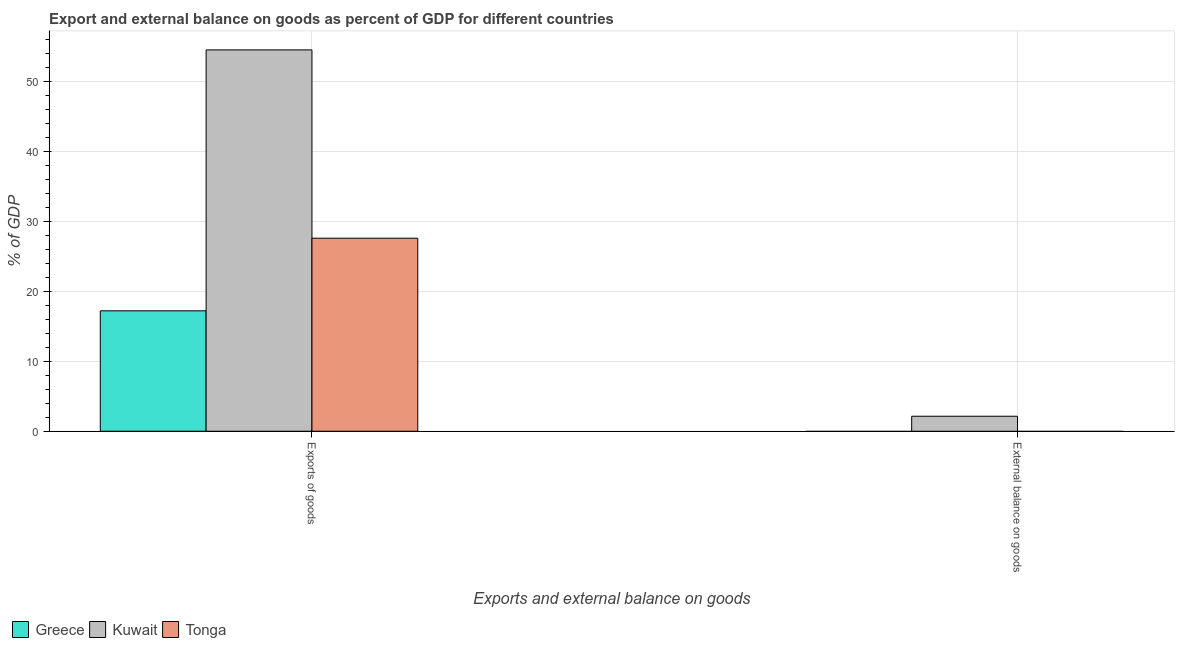Are the number of bars per tick equal to the number of legend labels?
Offer a very short reply. No. What is the label of the 2nd group of bars from the left?
Your response must be concise. External balance on goods. What is the export of goods as percentage of gdp in Tonga?
Ensure brevity in your answer.  27.59. Across all countries, what is the maximum export of goods as percentage of gdp?
Offer a very short reply. 54.5. Across all countries, what is the minimum external balance on goods as percentage of gdp?
Your answer should be compact. 0. In which country was the external balance on goods as percentage of gdp maximum?
Provide a succinct answer. Kuwait. What is the total external balance on goods as percentage of gdp in the graph?
Give a very brief answer. 2.14. What is the difference between the export of goods as percentage of gdp in Tonga and that in Kuwait?
Give a very brief answer. -26.92. What is the difference between the export of goods as percentage of gdp in Kuwait and the external balance on goods as percentage of gdp in Tonga?
Give a very brief answer. 54.5. What is the average external balance on goods as percentage of gdp per country?
Your response must be concise. 0.71. What is the difference between the export of goods as percentage of gdp and external balance on goods as percentage of gdp in Kuwait?
Provide a succinct answer. 52.36. In how many countries, is the external balance on goods as percentage of gdp greater than 6 %?
Provide a succinct answer. 0. What is the ratio of the export of goods as percentage of gdp in Tonga to that in Greece?
Provide a short and direct response. 1.6. In how many countries, is the export of goods as percentage of gdp greater than the average export of goods as percentage of gdp taken over all countries?
Offer a very short reply. 1. Are all the bars in the graph horizontal?
Ensure brevity in your answer.  No. How many countries are there in the graph?
Your answer should be compact. 3. What is the difference between two consecutive major ticks on the Y-axis?
Ensure brevity in your answer.  10. Are the values on the major ticks of Y-axis written in scientific E-notation?
Your answer should be compact. No. Where does the legend appear in the graph?
Ensure brevity in your answer.  Bottom left. How many legend labels are there?
Ensure brevity in your answer.  3. How are the legend labels stacked?
Keep it short and to the point. Horizontal. What is the title of the graph?
Provide a succinct answer. Export and external balance on goods as percent of GDP for different countries. Does "Liberia" appear as one of the legend labels in the graph?
Your answer should be compact. No. What is the label or title of the X-axis?
Make the answer very short. Exports and external balance on goods. What is the label or title of the Y-axis?
Provide a succinct answer. % of GDP. What is the % of GDP of Greece in Exports of goods?
Your response must be concise. 17.21. What is the % of GDP in Kuwait in Exports of goods?
Your response must be concise. 54.5. What is the % of GDP in Tonga in Exports of goods?
Offer a very short reply. 27.59. What is the % of GDP in Kuwait in External balance on goods?
Your response must be concise. 2.14. What is the % of GDP of Tonga in External balance on goods?
Your answer should be very brief. 0. Across all Exports and external balance on goods, what is the maximum % of GDP of Greece?
Make the answer very short. 17.21. Across all Exports and external balance on goods, what is the maximum % of GDP of Kuwait?
Make the answer very short. 54.5. Across all Exports and external balance on goods, what is the maximum % of GDP in Tonga?
Offer a very short reply. 27.59. Across all Exports and external balance on goods, what is the minimum % of GDP of Greece?
Provide a short and direct response. 0. Across all Exports and external balance on goods, what is the minimum % of GDP in Kuwait?
Ensure brevity in your answer.  2.14. Across all Exports and external balance on goods, what is the minimum % of GDP of Tonga?
Offer a terse response. 0. What is the total % of GDP in Greece in the graph?
Provide a short and direct response. 17.21. What is the total % of GDP in Kuwait in the graph?
Ensure brevity in your answer.  56.65. What is the total % of GDP in Tonga in the graph?
Provide a succinct answer. 27.59. What is the difference between the % of GDP in Kuwait in Exports of goods and that in External balance on goods?
Give a very brief answer. 52.36. What is the difference between the % of GDP in Greece in Exports of goods and the % of GDP in Kuwait in External balance on goods?
Make the answer very short. 15.07. What is the average % of GDP of Greece per Exports and external balance on goods?
Provide a short and direct response. 8.6. What is the average % of GDP of Kuwait per Exports and external balance on goods?
Your response must be concise. 28.32. What is the average % of GDP in Tonga per Exports and external balance on goods?
Offer a very short reply. 13.79. What is the difference between the % of GDP in Greece and % of GDP in Kuwait in Exports of goods?
Give a very brief answer. -37.3. What is the difference between the % of GDP of Greece and % of GDP of Tonga in Exports of goods?
Your answer should be very brief. -10.38. What is the difference between the % of GDP of Kuwait and % of GDP of Tonga in Exports of goods?
Your answer should be compact. 26.92. What is the ratio of the % of GDP in Kuwait in Exports of goods to that in External balance on goods?
Ensure brevity in your answer.  25.46. What is the difference between the highest and the second highest % of GDP of Kuwait?
Your answer should be very brief. 52.36. What is the difference between the highest and the lowest % of GDP in Greece?
Provide a succinct answer. 17.21. What is the difference between the highest and the lowest % of GDP in Kuwait?
Provide a short and direct response. 52.36. What is the difference between the highest and the lowest % of GDP of Tonga?
Make the answer very short. 27.59. 